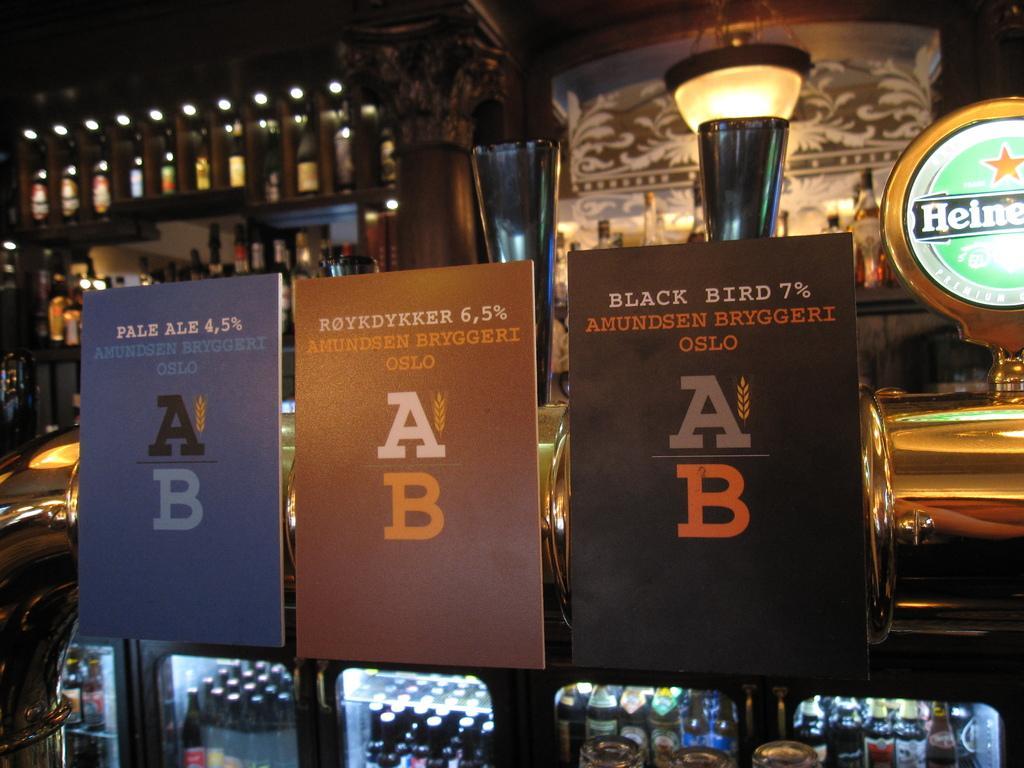Can you describe this image briefly? In this image we can see boards on which we can see some text and bottles kept in the refrigerator. The background of the image is slightly blurred, where we can see bottles kept on the shelf, ceiling light and the different pattern on the wall. 